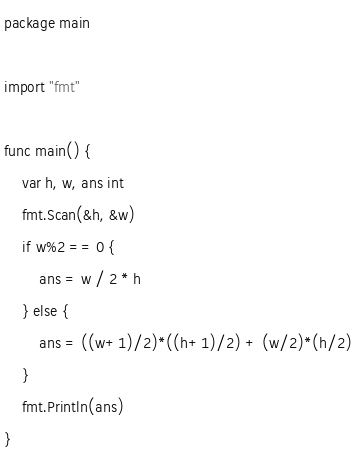<code> <loc_0><loc_0><loc_500><loc_500><_Go_>package main

import "fmt"

func main() {
	var h, w, ans int
	fmt.Scan(&h, &w)
	if w%2 == 0 {
		ans = w / 2 * h
	} else {
		ans = ((w+1)/2)*((h+1)/2) + (w/2)*(h/2)
	}
	fmt.Println(ans)
}
</code> 